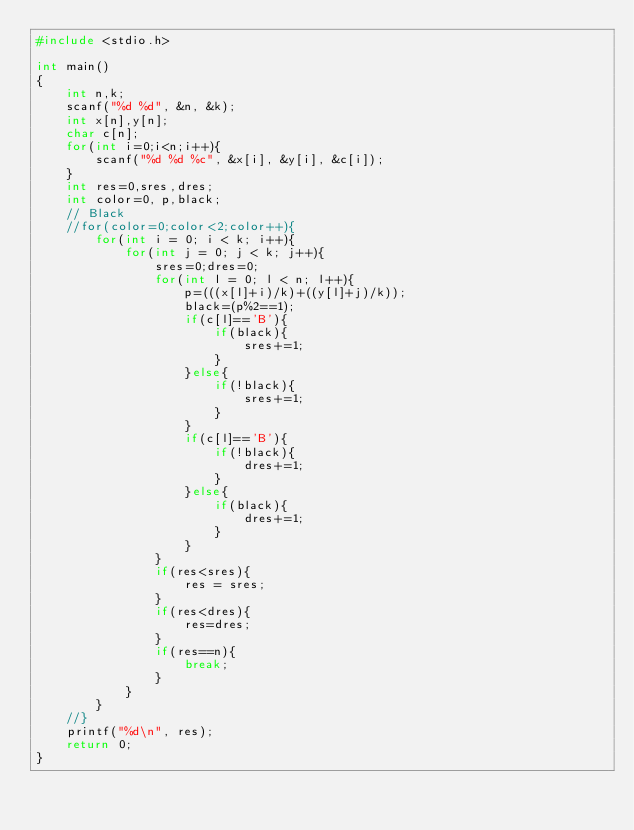Convert code to text. <code><loc_0><loc_0><loc_500><loc_500><_C_>#include <stdio.h>

int main()
{
    int n,k;
    scanf("%d %d", &n, &k);
    int x[n],y[n];
    char c[n];
    for(int i=0;i<n;i++){
        scanf("%d %d %c", &x[i], &y[i], &c[i]);
    }
    int res=0,sres,dres;
    int color=0, p,black;
    // Black
    //for(color=0;color<2;color++){
        for(int i = 0; i < k; i++){
            for(int j = 0; j < k; j++){
                sres=0;dres=0;
                for(int l = 0; l < n; l++){
                    p=(((x[l]+i)/k)+((y[l]+j)/k));
                    black=(p%2==1);
                    if(c[l]=='B'){
                        if(black){
                            sres+=1;
                        }
                    }else{
                        if(!black){
                            sres+=1;
                        }
                    }
                    if(c[l]=='B'){
                        if(!black){
                            dres+=1;
                        }
                    }else{
                        if(black){
                            dres+=1;
                        }
                    }
                }
                if(res<sres){
                    res = sres;
                }
                if(res<dres){
                    res=dres;
                }
                if(res==n){
                    break;
                }
            }
        }
    //}
    printf("%d\n", res);
    return 0;
}
</code> 